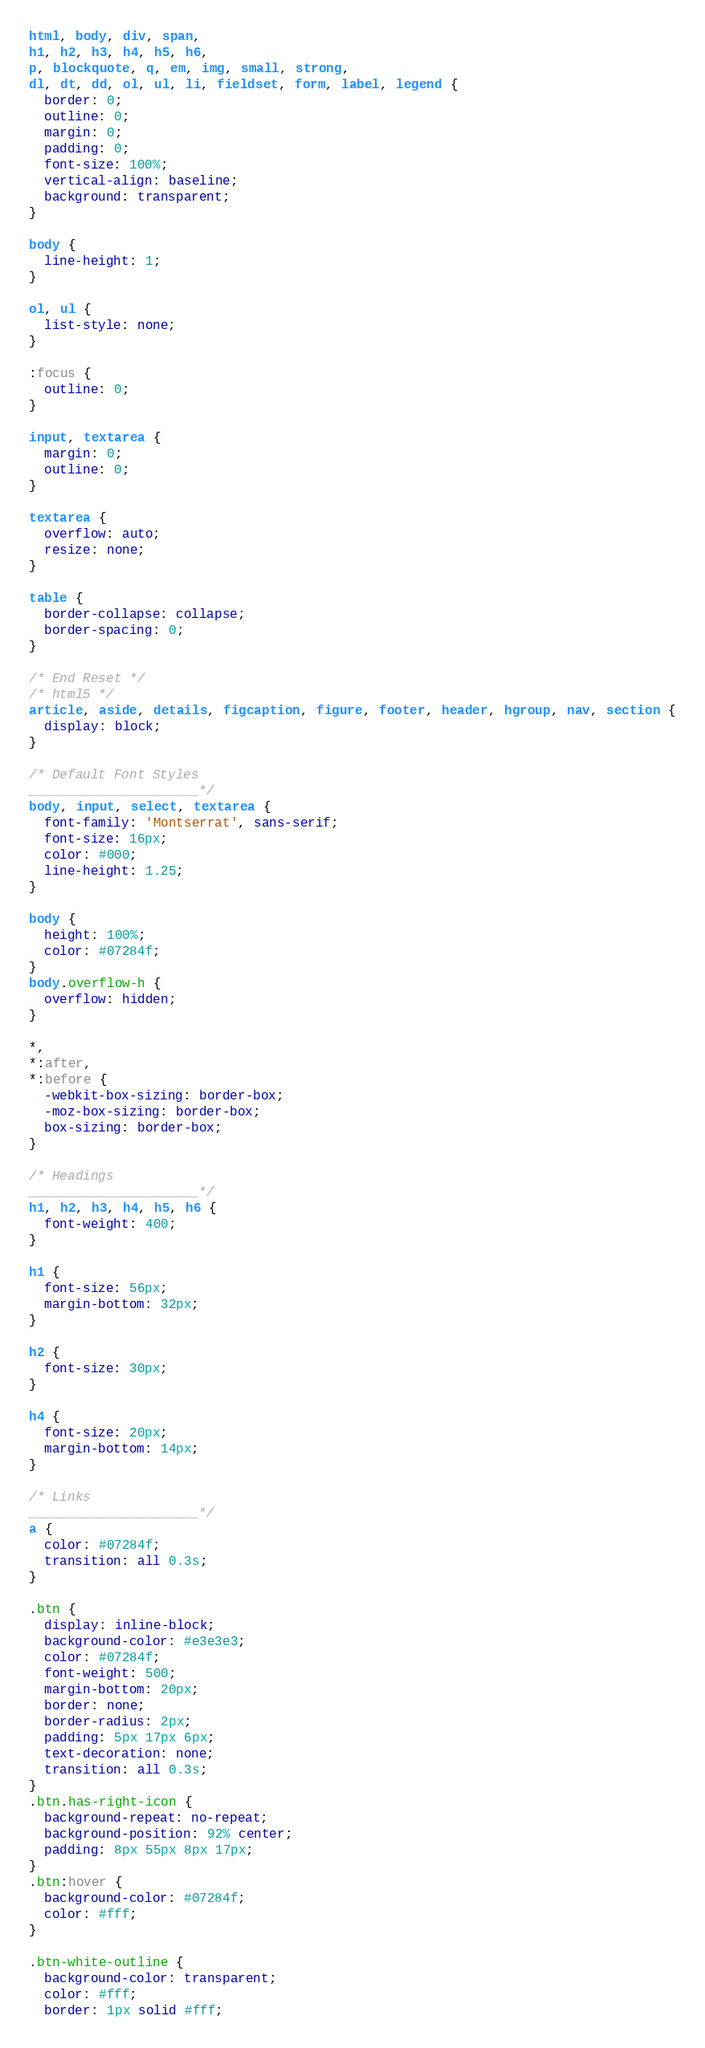<code> <loc_0><loc_0><loc_500><loc_500><_CSS_>html, body, div, span,
h1, h2, h3, h4, h5, h6,
p, blockquote, q, em, img, small, strong,
dl, dt, dd, ol, ul, li, fieldset, form, label, legend {
  border: 0;
  outline: 0;
  margin: 0;
  padding: 0;
  font-size: 100%;
  vertical-align: baseline;
  background: transparent;
}

body {
  line-height: 1;
}

ol, ul {
  list-style: none;
}

:focus {
  outline: 0;
}

input, textarea {
  margin: 0;
  outline: 0;
}

textarea {
  overflow: auto;
  resize: none;
}

table {
  border-collapse: collapse;
  border-spacing: 0;
}

/* End Reset */
/* html5 */
article, aside, details, figcaption, figure, footer, header, hgroup, nav, section {
  display: block;
}

/* Default Font Styles
______________________*/
body, input, select, textarea {
  font-family: 'Montserrat', sans-serif;
  font-size: 16px;
  color: #000;
  line-height: 1.25;
}

body {
  height: 100%;
  color: #07284f;
}
body.overflow-h {
  overflow: hidden;
}

*,
*:after,
*:before {
  -webkit-box-sizing: border-box;
  -moz-box-sizing: border-box;
  box-sizing: border-box;
}

/* Headings
______________________*/
h1, h2, h3, h4, h5, h6 {
  font-weight: 400;
}

h1 {
  font-size: 56px;
  margin-bottom: 32px;
}

h2 {
  font-size: 30px;
}

h4 {
  font-size: 20px;
  margin-bottom: 14px;
}

/* Links
______________________*/
a {
  color: #07284f;
  transition: all 0.3s;
}

.btn {
  display: inline-block;
  background-color: #e3e3e3;
  color: #07284f;
  font-weight: 500;
  margin-bottom: 20px;
  border: none;
  border-radius: 2px;
  padding: 5px 17px 6px;
  text-decoration: none;
  transition: all 0.3s;
}
.btn.has-right-icon {
  background-repeat: no-repeat;
  background-position: 92% center;
  padding: 8px 55px 8px 17px;
}
.btn:hover {
  background-color: #07284f;
  color: #fff;
}

.btn-white-outline {
  background-color: transparent;
  color: #fff;
  border: 1px solid #fff;</code> 